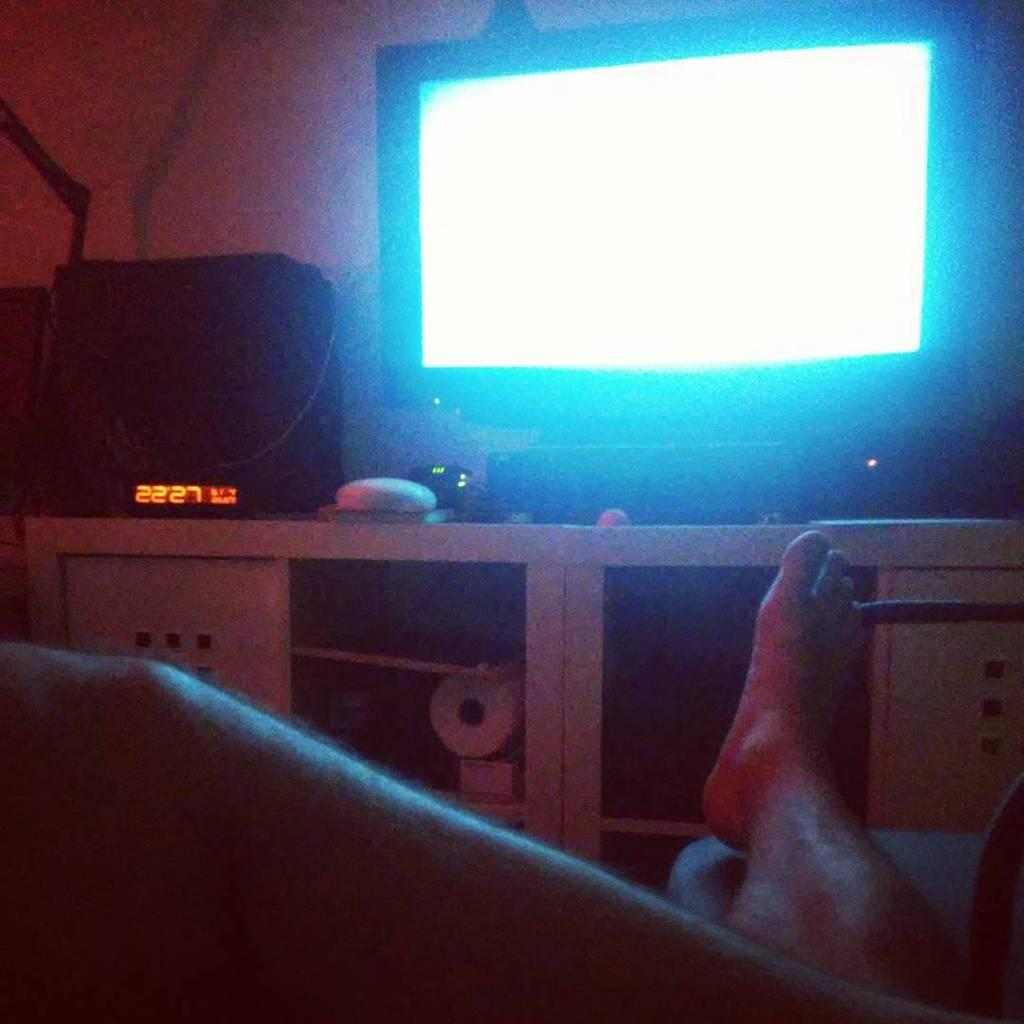<image>
Describe the image concisely. An orange digital display has the numbers 2227 on it. 